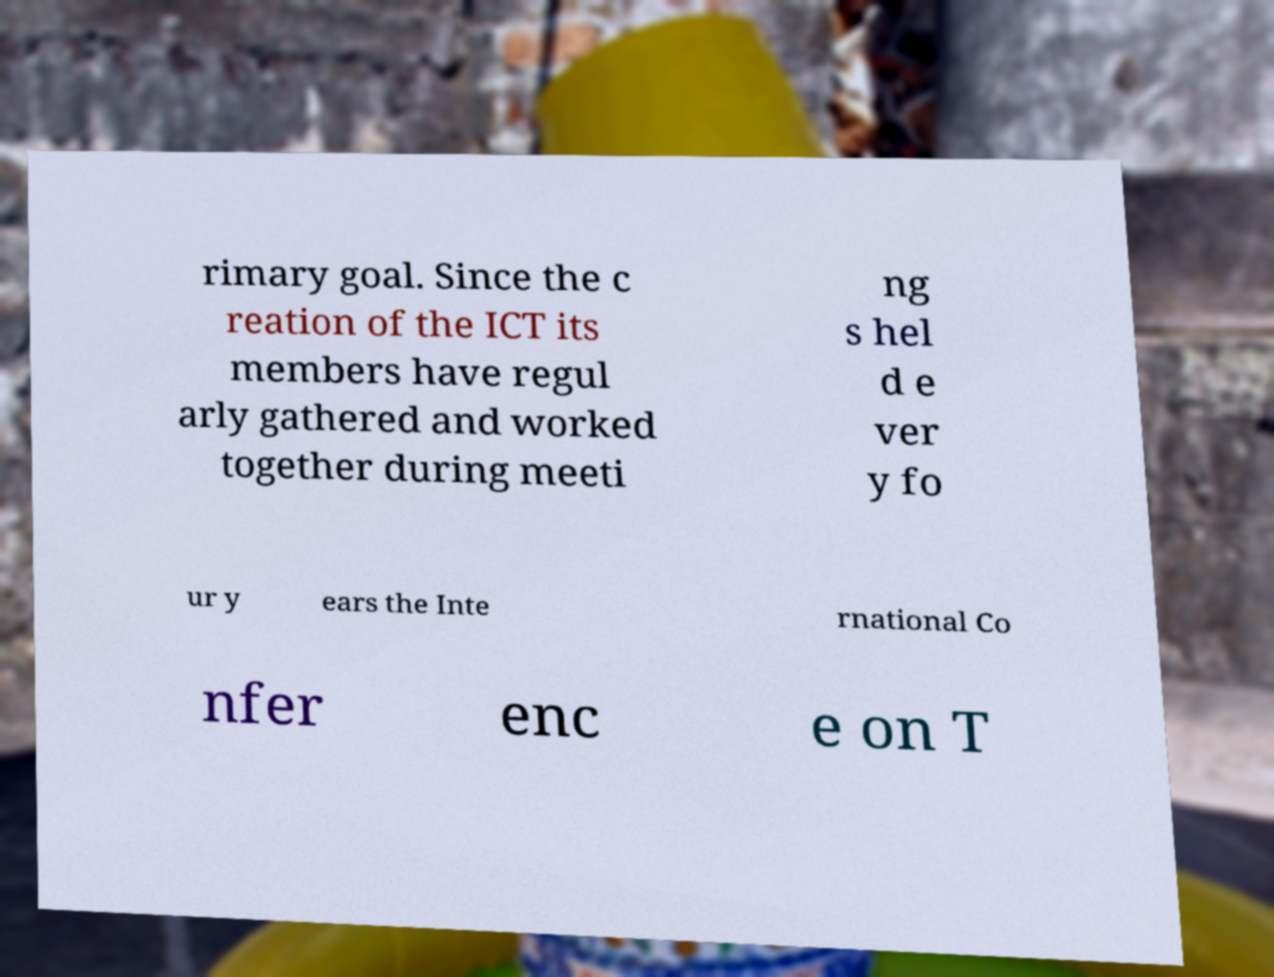What messages or text are displayed in this image? I need them in a readable, typed format. rimary goal. Since the c reation of the ICT its members have regul arly gathered and worked together during meeti ng s hel d e ver y fo ur y ears the Inte rnational Co nfer enc e on T 